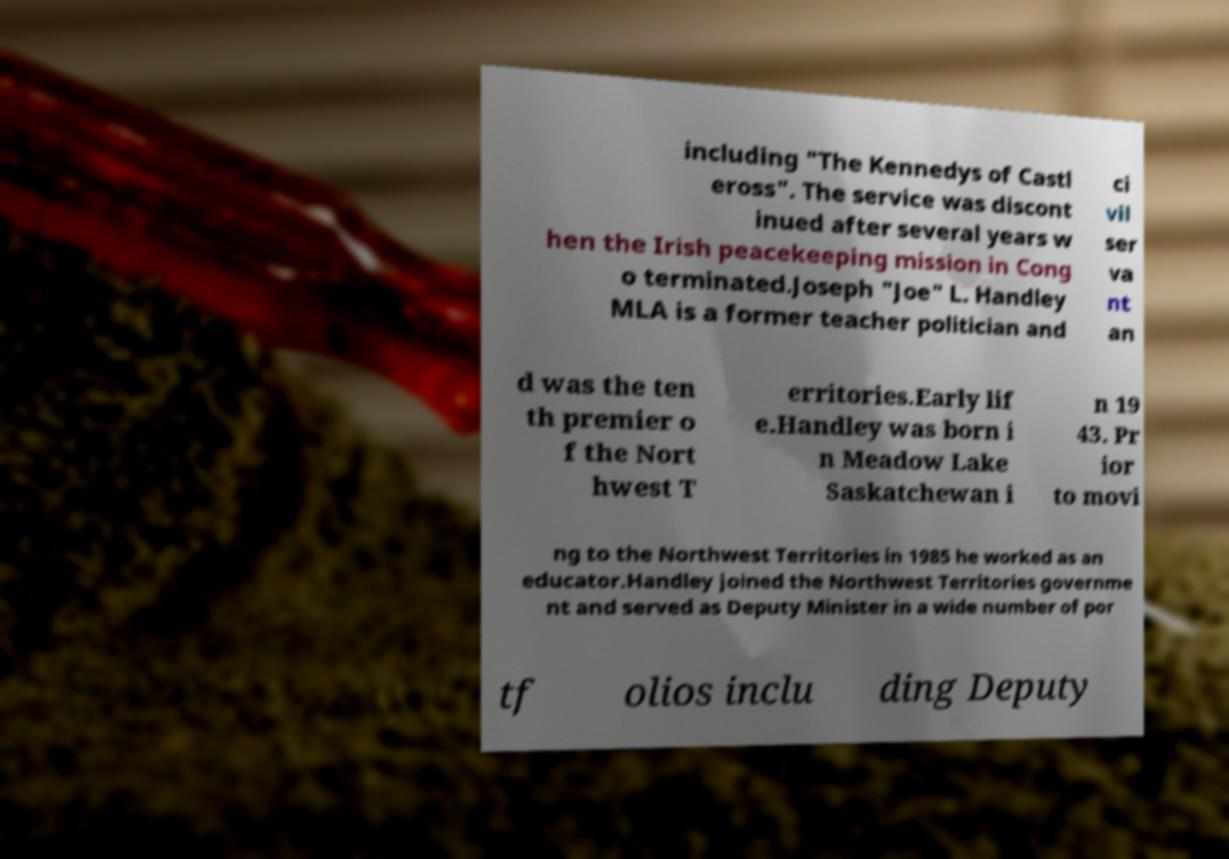Could you extract and type out the text from this image? including "The Kennedys of Castl eross". The service was discont inued after several years w hen the Irish peacekeeping mission in Cong o terminated.Joseph "Joe" L. Handley MLA is a former teacher politician and ci vil ser va nt an d was the ten th premier o f the Nort hwest T erritories.Early lif e.Handley was born i n Meadow Lake Saskatchewan i n 19 43. Pr ior to movi ng to the Northwest Territories in 1985 he worked as an educator.Handley joined the Northwest Territories governme nt and served as Deputy Minister in a wide number of por tf olios inclu ding Deputy 